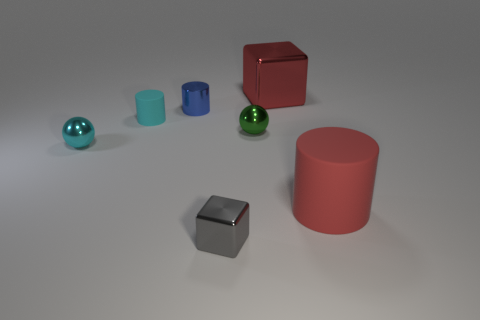Is the shape of the tiny gray metallic thing the same as the big red shiny thing?
Offer a very short reply. Yes. The other object that is the same shape as the cyan metal object is what color?
Offer a terse response. Green. What number of blocks have the same color as the large rubber object?
Your answer should be very brief. 1. What number of things are tiny cyan things that are right of the cyan sphere or yellow things?
Offer a terse response. 1. There is a rubber object that is to the left of the tiny gray thing; what size is it?
Give a very brief answer. Small. Is the number of small shiny cylinders less than the number of shiny spheres?
Keep it short and to the point. Yes. Are the small sphere to the left of the gray shiny cube and the large red thing that is in front of the big red metal thing made of the same material?
Your answer should be compact. No. What is the shape of the red object behind the small blue object left of the large red object that is behind the big red matte thing?
Provide a succinct answer. Cube. What number of large gray spheres are the same material as the cyan sphere?
Ensure brevity in your answer.  0. There is a cylinder that is left of the small blue metal cylinder; how many red rubber cylinders are on the right side of it?
Your answer should be very brief. 1. 